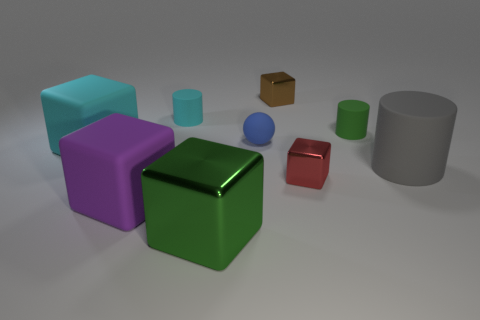Add 1 brown shiny cylinders. How many objects exist? 10 Subtract all big cyan matte cubes. How many cubes are left? 4 Subtract all cyan cubes. How many cubes are left? 4 Subtract all cylinders. How many objects are left? 6 Subtract 3 blocks. How many blocks are left? 2 Subtract all tiny gray metal things. Subtract all big cyan matte things. How many objects are left? 8 Add 6 large purple things. How many large purple things are left? 7 Add 4 big blocks. How many big blocks exist? 7 Subtract 0 purple cylinders. How many objects are left? 9 Subtract all brown cylinders. Subtract all yellow balls. How many cylinders are left? 3 